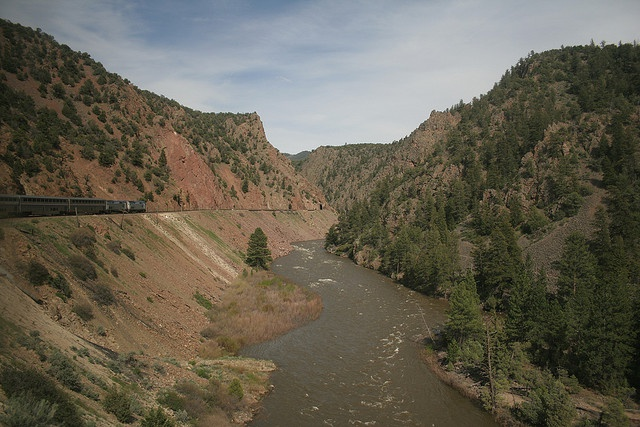Describe the objects in this image and their specific colors. I can see a train in gray and black tones in this image. 